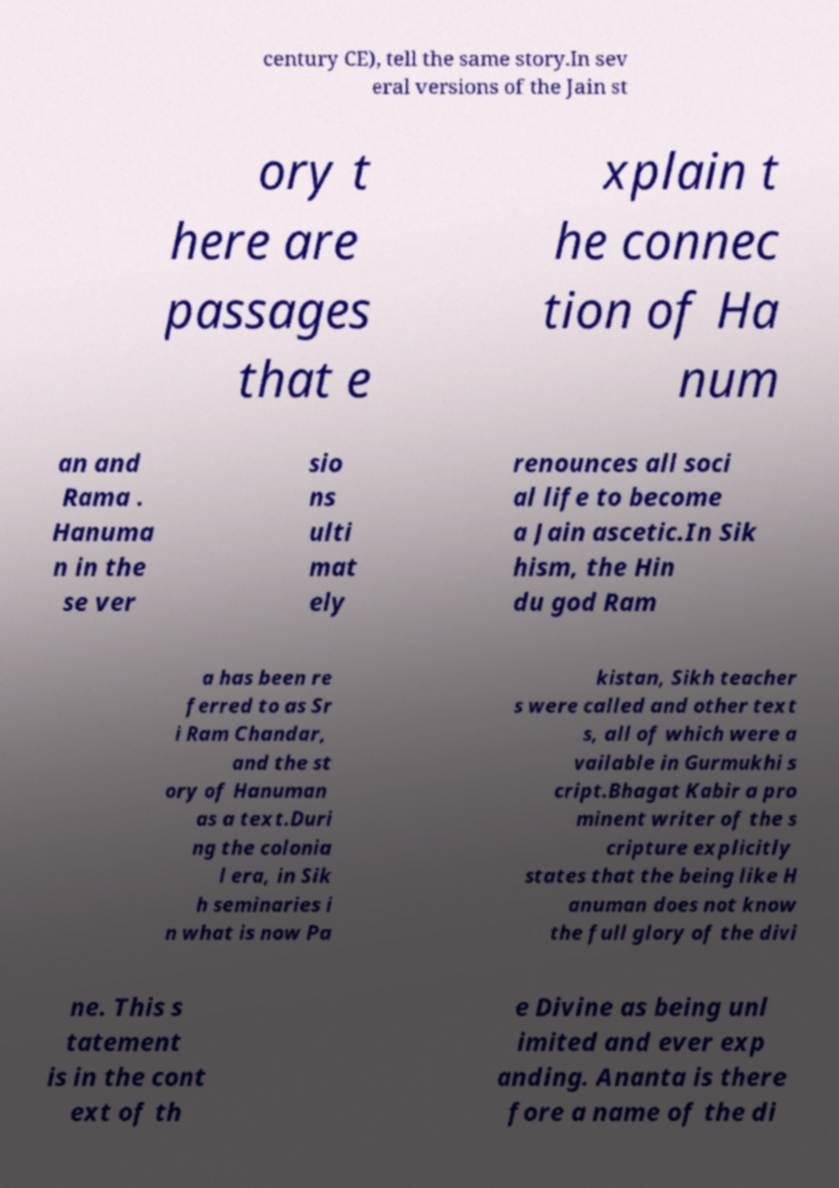For documentation purposes, I need the text within this image transcribed. Could you provide that? century CE), tell the same story.In sev eral versions of the Jain st ory t here are passages that e xplain t he connec tion of Ha num an and Rama . Hanuma n in the se ver sio ns ulti mat ely renounces all soci al life to become a Jain ascetic.In Sik hism, the Hin du god Ram a has been re ferred to as Sr i Ram Chandar, and the st ory of Hanuman as a text.Duri ng the colonia l era, in Sik h seminaries i n what is now Pa kistan, Sikh teacher s were called and other text s, all of which were a vailable in Gurmukhi s cript.Bhagat Kabir a pro minent writer of the s cripture explicitly states that the being like H anuman does not know the full glory of the divi ne. This s tatement is in the cont ext of th e Divine as being unl imited and ever exp anding. Ananta is there fore a name of the di 